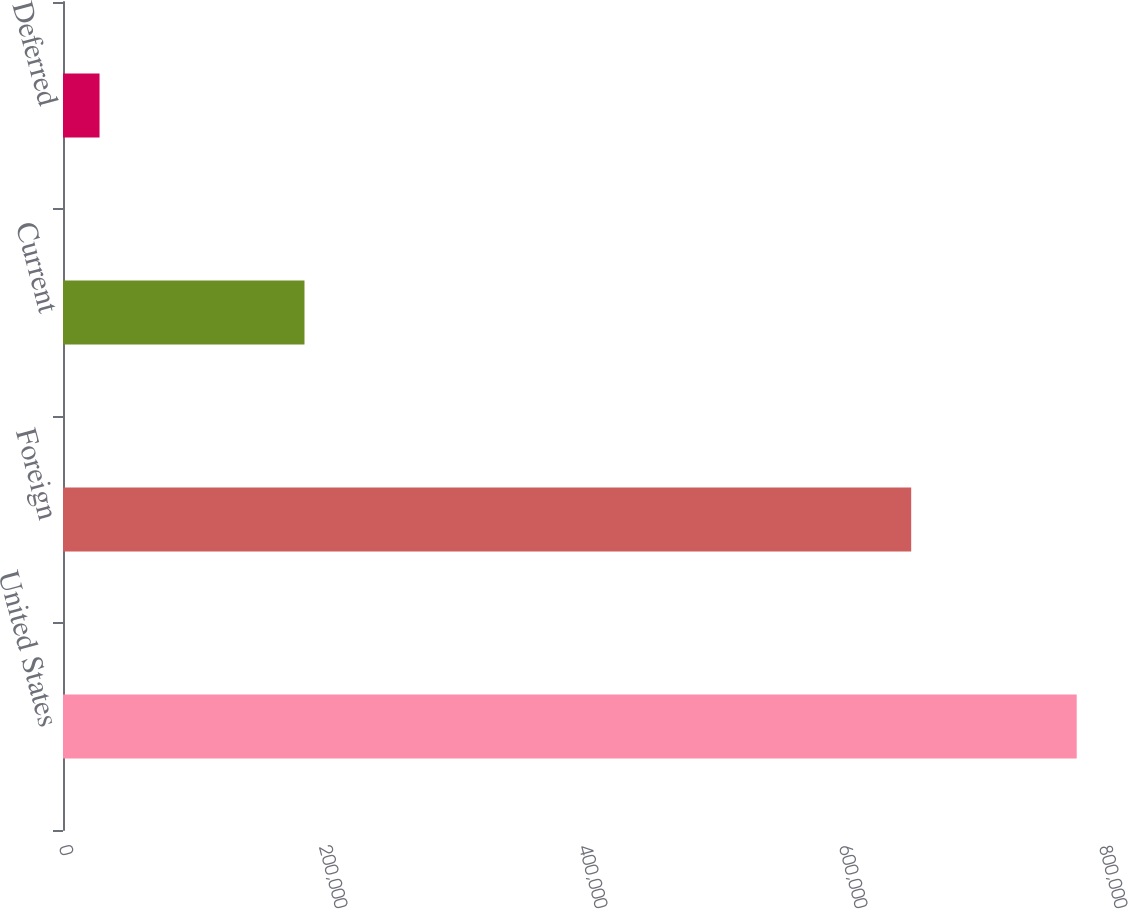Convert chart. <chart><loc_0><loc_0><loc_500><loc_500><bar_chart><fcel>United States<fcel>Foreign<fcel>Current<fcel>Deferred<nl><fcel>779782<fcel>652458<fcel>185761<fcel>28108<nl></chart> 